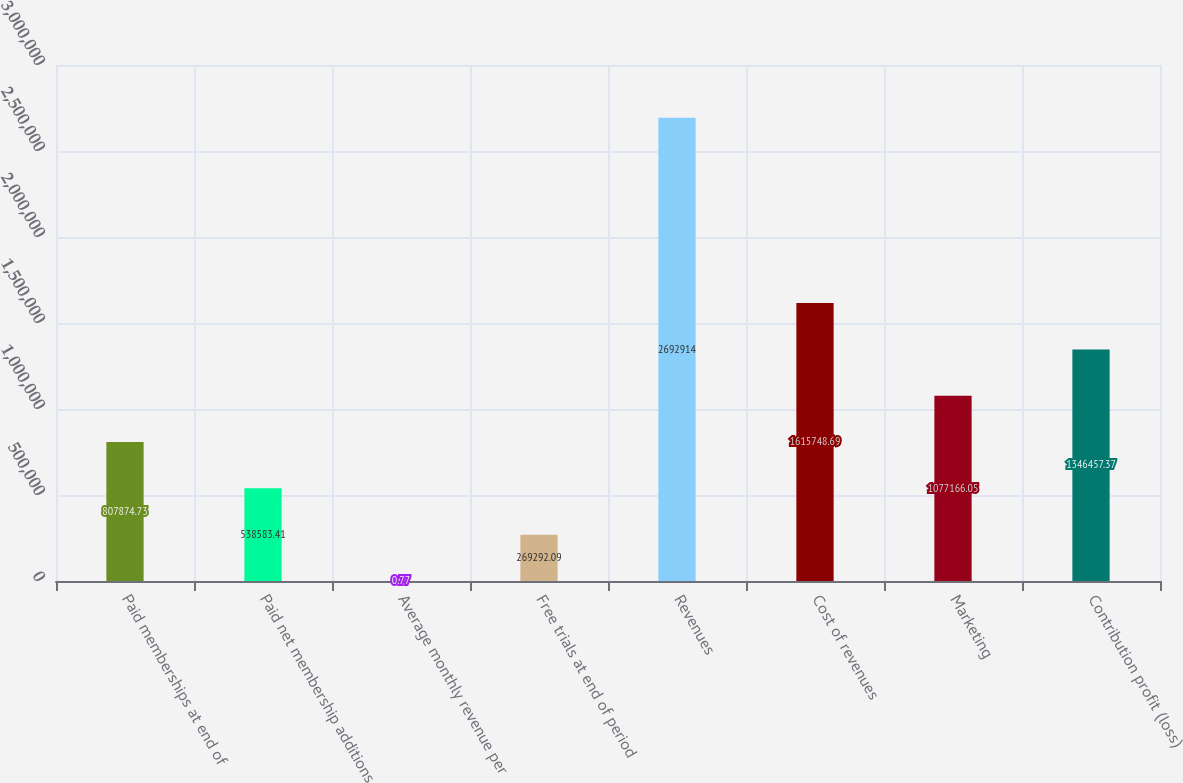Convert chart. <chart><loc_0><loc_0><loc_500><loc_500><bar_chart><fcel>Paid memberships at end of<fcel>Paid net membership additions<fcel>Average monthly revenue per<fcel>Free trials at end of period<fcel>Revenues<fcel>Cost of revenues<fcel>Marketing<fcel>Contribution profit (loss)<nl><fcel>807875<fcel>538583<fcel>0.77<fcel>269292<fcel>2.69291e+06<fcel>1.61575e+06<fcel>1.07717e+06<fcel>1.34646e+06<nl></chart> 